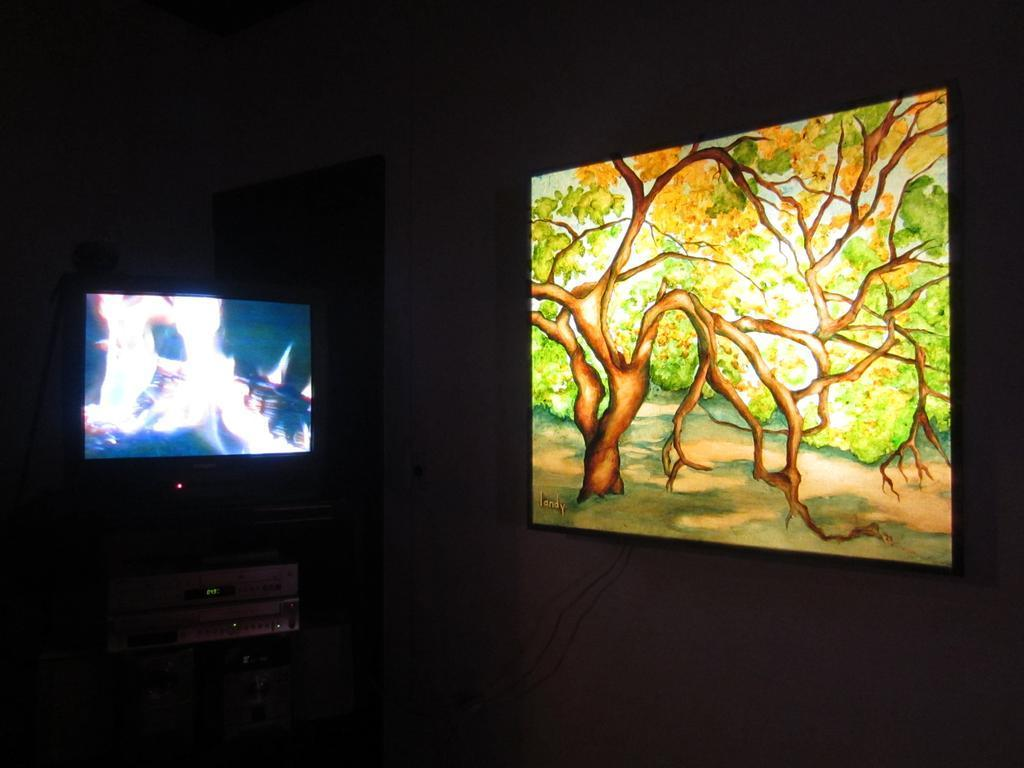What is located on the right side of the image? There is a frame on the wall in the foreground of the image. Where is the television positioned in the image? The television is on the left side of the image. What is present on the left side of the image besides the television? There is a device on the left side of the image. What type of eggnog is being served in the image? There is no eggnog present in the image. Can you see any hearts in the image? There are no hearts visible in the image. 